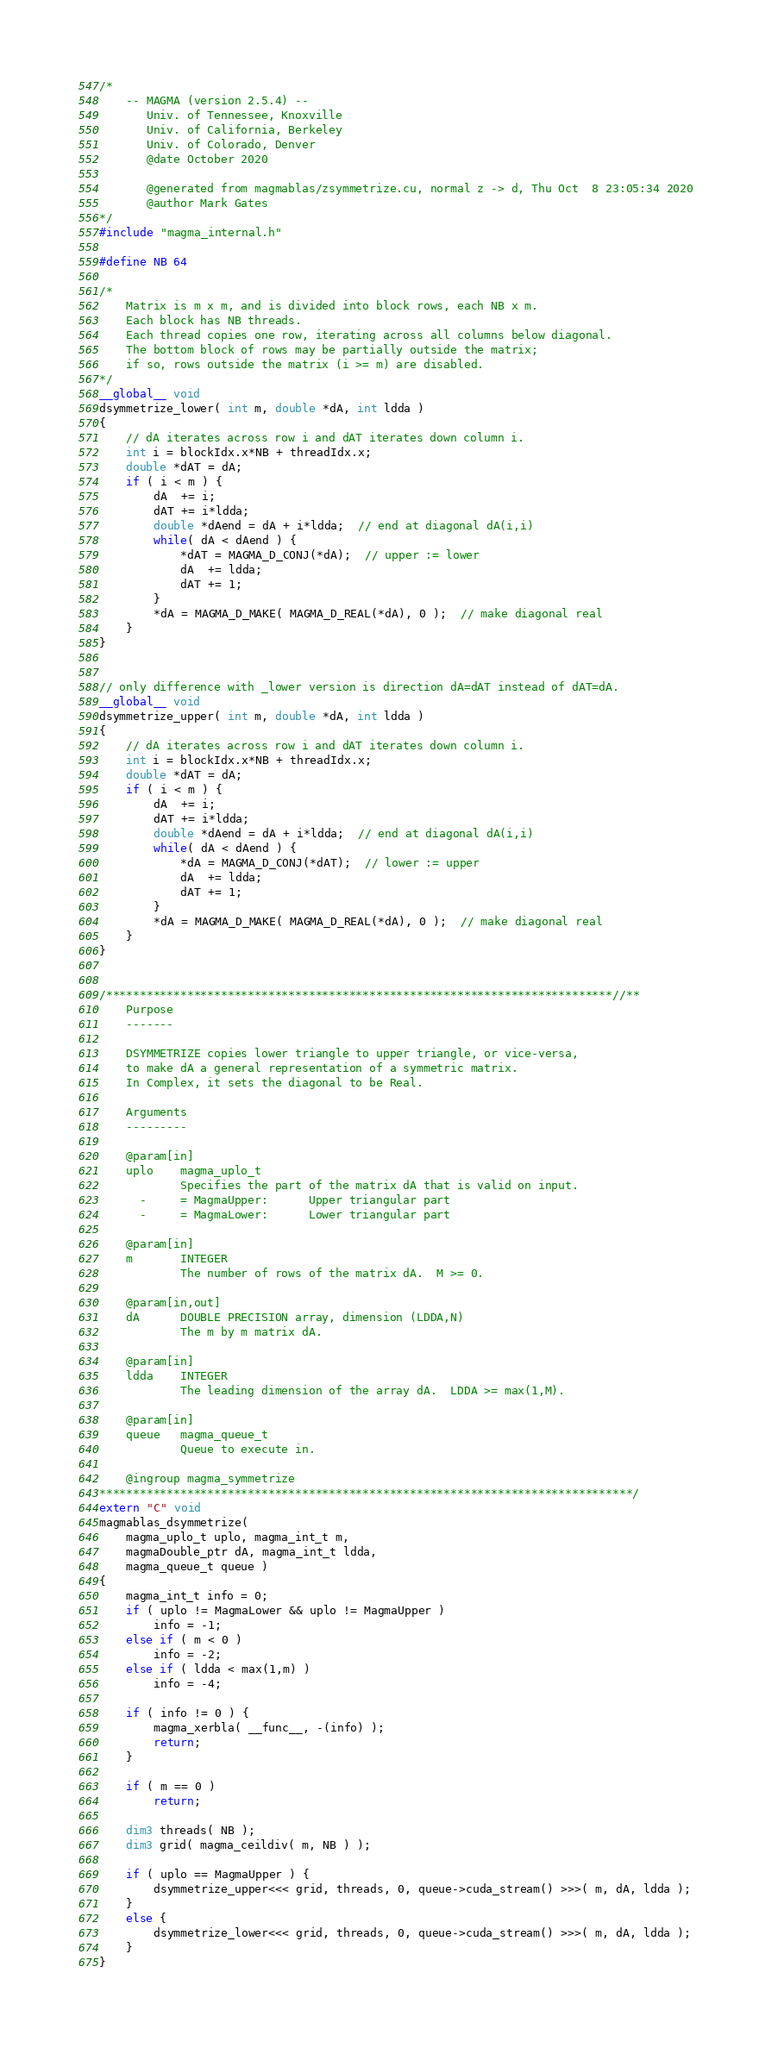Convert code to text. <code><loc_0><loc_0><loc_500><loc_500><_Cuda_>/*
    -- MAGMA (version 2.5.4) --
       Univ. of Tennessee, Knoxville
       Univ. of California, Berkeley
       Univ. of Colorado, Denver
       @date October 2020

       @generated from magmablas/zsymmetrize.cu, normal z -> d, Thu Oct  8 23:05:34 2020
       @author Mark Gates
*/
#include "magma_internal.h"

#define NB 64

/*
    Matrix is m x m, and is divided into block rows, each NB x m.
    Each block has NB threads.
    Each thread copies one row, iterating across all columns below diagonal.
    The bottom block of rows may be partially outside the matrix;
    if so, rows outside the matrix (i >= m) are disabled.
*/
__global__ void
dsymmetrize_lower( int m, double *dA, int ldda )
{
    // dA iterates across row i and dAT iterates down column i.
    int i = blockIdx.x*NB + threadIdx.x;
    double *dAT = dA;
    if ( i < m ) {
        dA  += i;
        dAT += i*ldda;
        double *dAend = dA + i*ldda;  // end at diagonal dA(i,i)
        while( dA < dAend ) {
            *dAT = MAGMA_D_CONJ(*dA);  // upper := lower
            dA  += ldda;
            dAT += 1;
        }
        *dA = MAGMA_D_MAKE( MAGMA_D_REAL(*dA), 0 );  // make diagonal real
    }
}


// only difference with _lower version is direction dA=dAT instead of dAT=dA.
__global__ void
dsymmetrize_upper( int m, double *dA, int ldda )
{
    // dA iterates across row i and dAT iterates down column i.
    int i = blockIdx.x*NB + threadIdx.x;
    double *dAT = dA;
    if ( i < m ) {
        dA  += i;
        dAT += i*ldda;
        double *dAend = dA + i*ldda;  // end at diagonal dA(i,i)
        while( dA < dAend ) {
            *dA = MAGMA_D_CONJ(*dAT);  // lower := upper
            dA  += ldda;
            dAT += 1;
        }
        *dA = MAGMA_D_MAKE( MAGMA_D_REAL(*dA), 0 );  // make diagonal real
    }
}


/***************************************************************************//**
    Purpose
    -------
    
    DSYMMETRIZE copies lower triangle to upper triangle, or vice-versa,
    to make dA a general representation of a symmetric matrix.
    In Complex, it sets the diagonal to be Real.
    
    Arguments
    ---------
    
    @param[in]
    uplo    magma_uplo_t
            Specifies the part of the matrix dA that is valid on input.
      -     = MagmaUpper:      Upper triangular part
      -     = MagmaLower:      Lower triangular part
    
    @param[in]
    m       INTEGER
            The number of rows of the matrix dA.  M >= 0.
    
    @param[in,out]
    dA      DOUBLE PRECISION array, dimension (LDDA,N)
            The m by m matrix dA.
    
    @param[in]
    ldda    INTEGER
            The leading dimension of the array dA.  LDDA >= max(1,M).
    
    @param[in]
    queue   magma_queue_t
            Queue to execute in.

    @ingroup magma_symmetrize
*******************************************************************************/
extern "C" void
magmablas_dsymmetrize(
    magma_uplo_t uplo, magma_int_t m,
    magmaDouble_ptr dA, magma_int_t ldda,
    magma_queue_t queue )
{
    magma_int_t info = 0;
    if ( uplo != MagmaLower && uplo != MagmaUpper )
        info = -1;
    else if ( m < 0 )
        info = -2;
    else if ( ldda < max(1,m) )
        info = -4;
    
    if ( info != 0 ) {
        magma_xerbla( __func__, -(info) );
        return;
    }
    
    if ( m == 0 )
        return;
    
    dim3 threads( NB );
    dim3 grid( magma_ceildiv( m, NB ) );
    
    if ( uplo == MagmaUpper ) {
        dsymmetrize_upper<<< grid, threads, 0, queue->cuda_stream() >>>( m, dA, ldda );
    }
    else {
        dsymmetrize_lower<<< grid, threads, 0, queue->cuda_stream() >>>( m, dA, ldda );
    }
}
</code> 